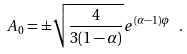Convert formula to latex. <formula><loc_0><loc_0><loc_500><loc_500>A _ { 0 } = \pm \sqrt { { \frac { 4 } { 3 ( 1 - \alpha ) } } } e ^ { ( \alpha - 1 ) \phi } \ .</formula> 